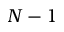Convert formula to latex. <formula><loc_0><loc_0><loc_500><loc_500>N - 1</formula> 